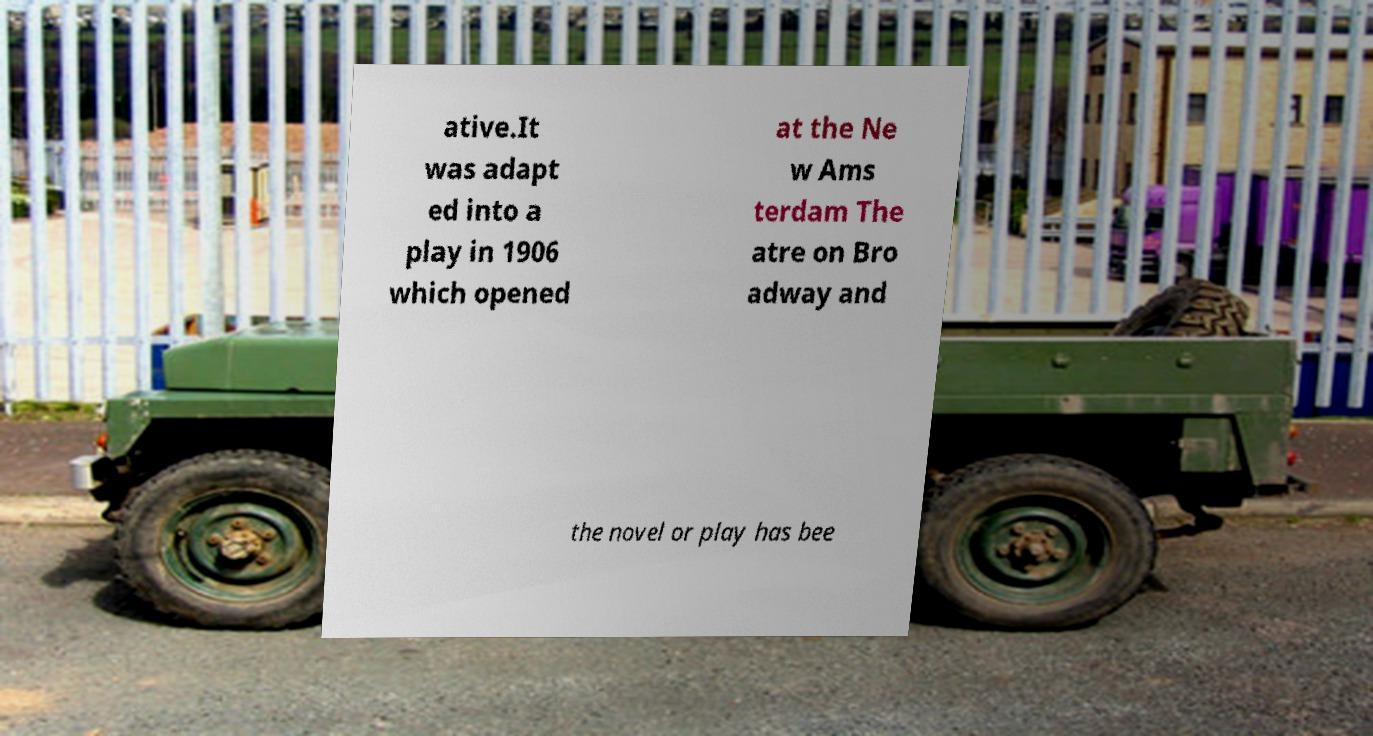Please read and relay the text visible in this image. What does it say? ative.It was adapt ed into a play in 1906 which opened at the Ne w Ams terdam The atre on Bro adway and the novel or play has bee 